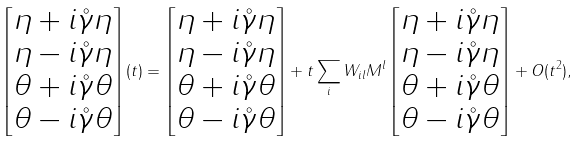Convert formula to latex. <formula><loc_0><loc_0><loc_500><loc_500>\begin{bmatrix} \eta + i { \mathring { \gamma } } \eta \\ \eta - i { \mathring { \gamma } } \eta \\ \theta + i { \mathring { \gamma } } \theta \\ \theta - i { \mathring { \gamma } } \theta \end{bmatrix} ( t ) = \begin{bmatrix} \eta + i { \mathring { \gamma } } \eta \\ \eta - i { \mathring { \gamma } } \eta \\ \theta + i { \mathring { \gamma } } \theta \\ \theta - i { \mathring { \gamma } } \theta \end{bmatrix} + t \sum _ { i } W _ { i l } M ^ { l } \begin{bmatrix} \eta + i { \mathring { \gamma } } \eta \\ \eta - i { \mathring { \gamma } } \eta \\ \theta + i { \mathring { \gamma } } \theta \\ \theta - i { \mathring { \gamma } } \theta \end{bmatrix} + O ( t ^ { 2 } ) ,</formula> 